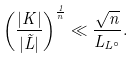Convert formula to latex. <formula><loc_0><loc_0><loc_500><loc_500>\left ( \frac { | K | } { | \tilde { L } | } \right ) ^ { \frac { 1 } { n } } \ll \frac { \sqrt { n } } { L _ { L ^ { \circ } } } .</formula> 